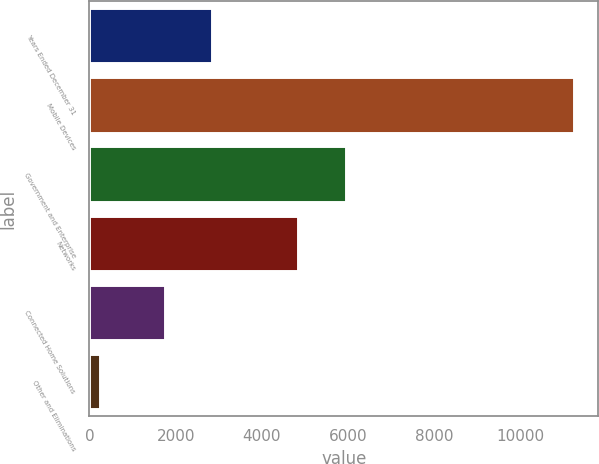<chart> <loc_0><loc_0><loc_500><loc_500><bar_chart><fcel>Years Ended December 31<fcel>Mobile Devices<fcel>Government and Enterprise<fcel>Networks<fcel>Connected Home Solutions<fcel>Other and Eliminations<nl><fcel>2844.6<fcel>11238<fcel>5945.6<fcel>4846<fcel>1745<fcel>242<nl></chart> 